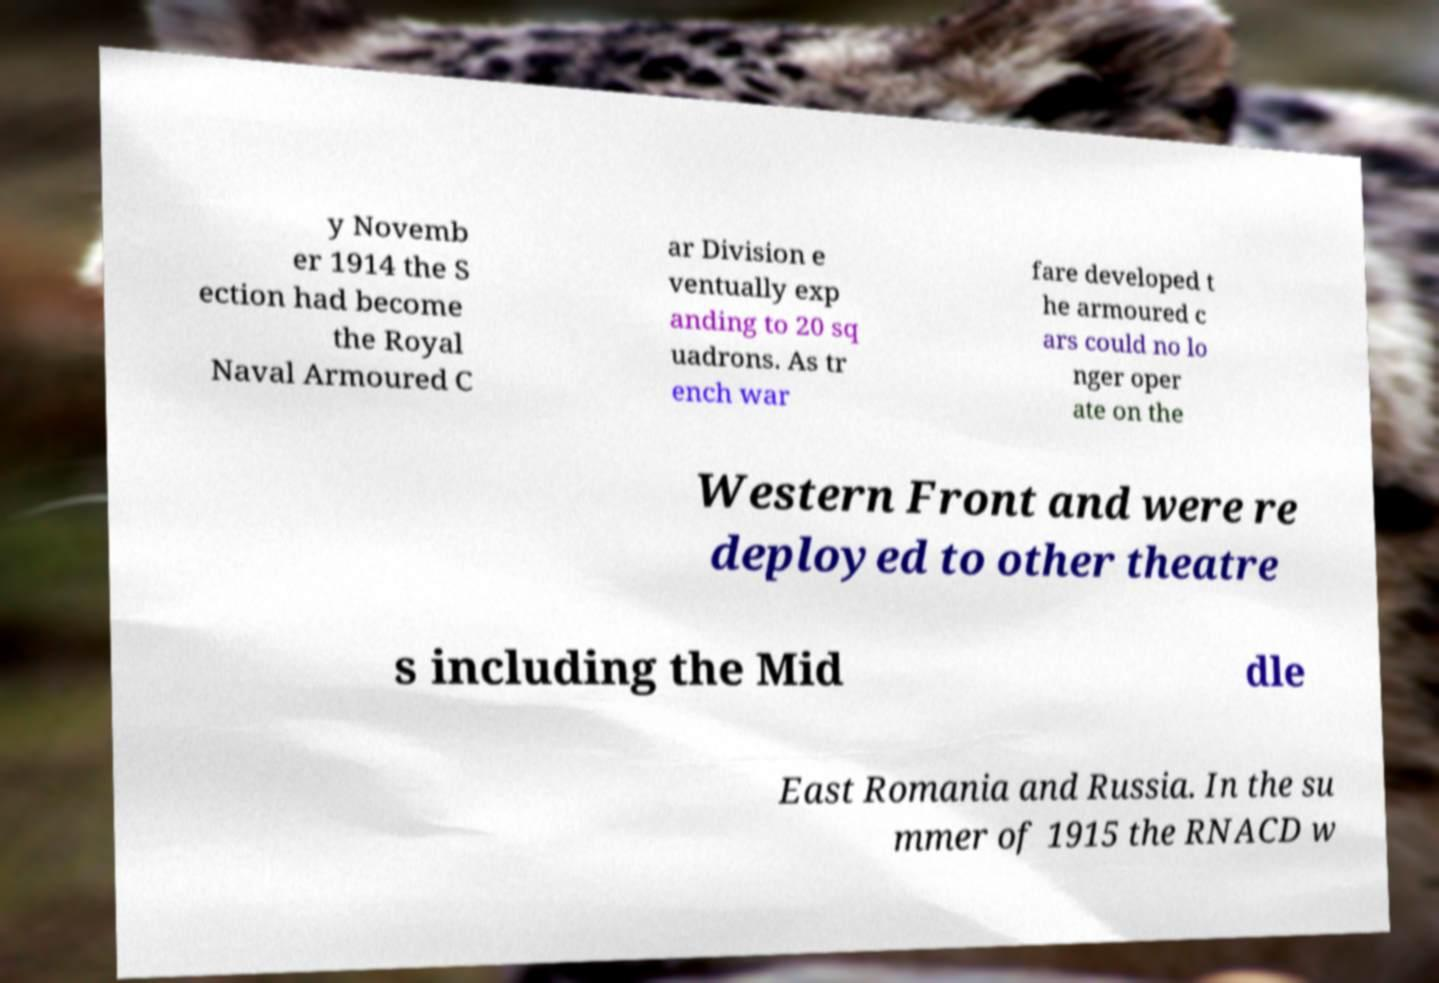Can you read and provide the text displayed in the image?This photo seems to have some interesting text. Can you extract and type it out for me? y Novemb er 1914 the S ection had become the Royal Naval Armoured C ar Division e ventually exp anding to 20 sq uadrons. As tr ench war fare developed t he armoured c ars could no lo nger oper ate on the Western Front and were re deployed to other theatre s including the Mid dle East Romania and Russia. In the su mmer of 1915 the RNACD w 